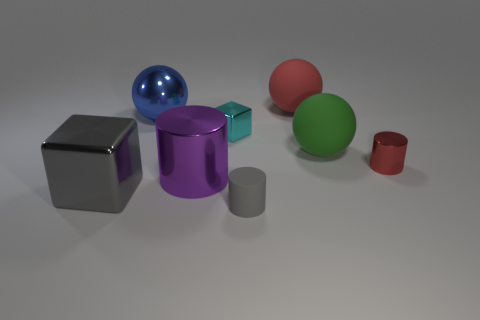Is there any other thing of the same color as the large cube?
Provide a short and direct response. Yes. Do the large object that is behind the blue ball and the small metallic cylinder have the same color?
Give a very brief answer. Yes. There is a small matte object; does it have the same color as the block that is in front of the big cylinder?
Keep it short and to the point. Yes. What is the shape of the big object that is the same color as the small rubber cylinder?
Ensure brevity in your answer.  Cube. There is a cylinder that is the same color as the big metal cube; what is its size?
Ensure brevity in your answer.  Small. What is the size of the gray object that is the same shape as the red metal thing?
Keep it short and to the point. Small. Does the large green ball have the same material as the gray object that is to the right of the cyan shiny object?
Offer a very short reply. Yes. How many cyan things are tiny blocks or big metal things?
Your answer should be very brief. 1. Are there any red things of the same size as the green rubber sphere?
Your response must be concise. Yes. There is a red thing in front of the big matte ball to the left of the matte ball that is in front of the small block; what is it made of?
Make the answer very short. Metal. 